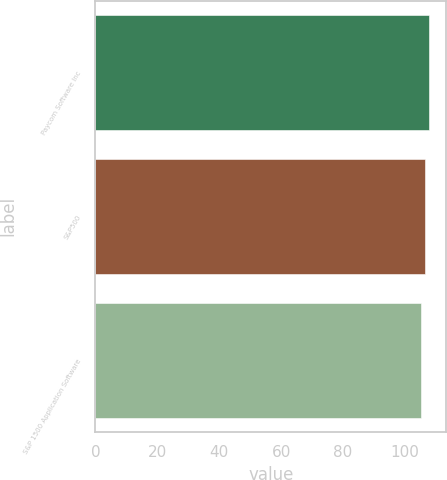Convert chart to OTSL. <chart><loc_0><loc_0><loc_500><loc_500><bar_chart><fcel>Paycom Software Inc<fcel>S&P500<fcel>S&P 1500 Application Software<nl><fcel>107.88<fcel>106.42<fcel>105.17<nl></chart> 